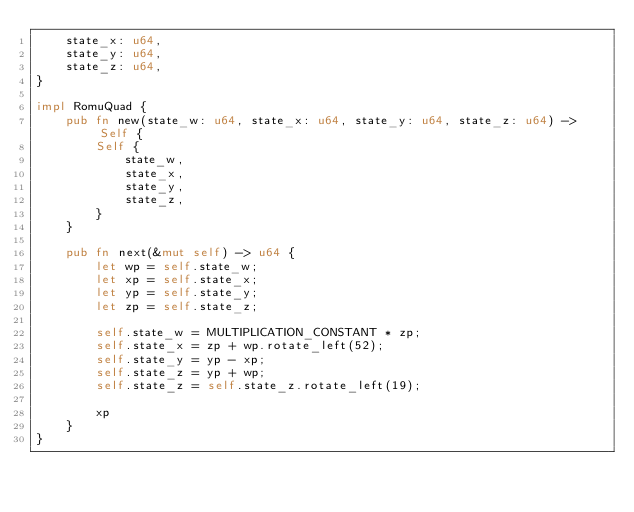Convert code to text. <code><loc_0><loc_0><loc_500><loc_500><_Rust_>    state_x: u64,
    state_y: u64,
    state_z: u64,
}

impl RomuQuad {
    pub fn new(state_w: u64, state_x: u64, state_y: u64, state_z: u64) -> Self {
        Self {
            state_w,
            state_x,
            state_y,
            state_z,
        }
    }

    pub fn next(&mut self) -> u64 {
        let wp = self.state_w;
        let xp = self.state_x;
        let yp = self.state_y;
        let zp = self.state_z;

        self.state_w = MULTIPLICATION_CONSTANT * zp;
        self.state_x = zp + wp.rotate_left(52);
        self.state_y = yp - xp;
        self.state_z = yp + wp;
        self.state_z = self.state_z.rotate_left(19);

        xp
    }
}
</code> 